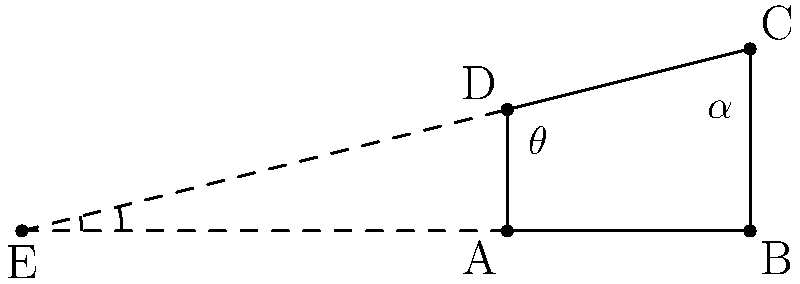Two Art Deco-style buildings in a historic district intersect at an angle. The first building's facade forms an angle of $\theta = 60°$ with the street, while the second building's facade forms an angle of $\alpha = 45°$ with the same street. What is the angle between the two building facades at their intersection point? To find the angle between the two building facades, we can follow these steps:

1) In the diagram, the street is represented by line AB, and the two building facades are represented by lines AC and AD.

2) The angle we're looking for is angle CED, which is the supplementary angle to AED.

3) We know that:
   - Angle BAC = $\theta = 60°$
   - Angle BAD = $\alpha = 45°$

4) The angle between the facades (CED) plus the angle between the facades and the street (BAC + BAD) must equal 180°, as they form a complete angle around point E.

5) We can express this as an equation:
   $CED + (BAC + BAD) = 180°$

6) Substituting the known values:
   $CED + (60° + 45°) = 180°$
   $CED + 105° = 180°$

7) Solving for CED:
   $CED = 180° - 105° = 75°$

Therefore, the angle between the two building facades is 75°.
Answer: $75°$ 